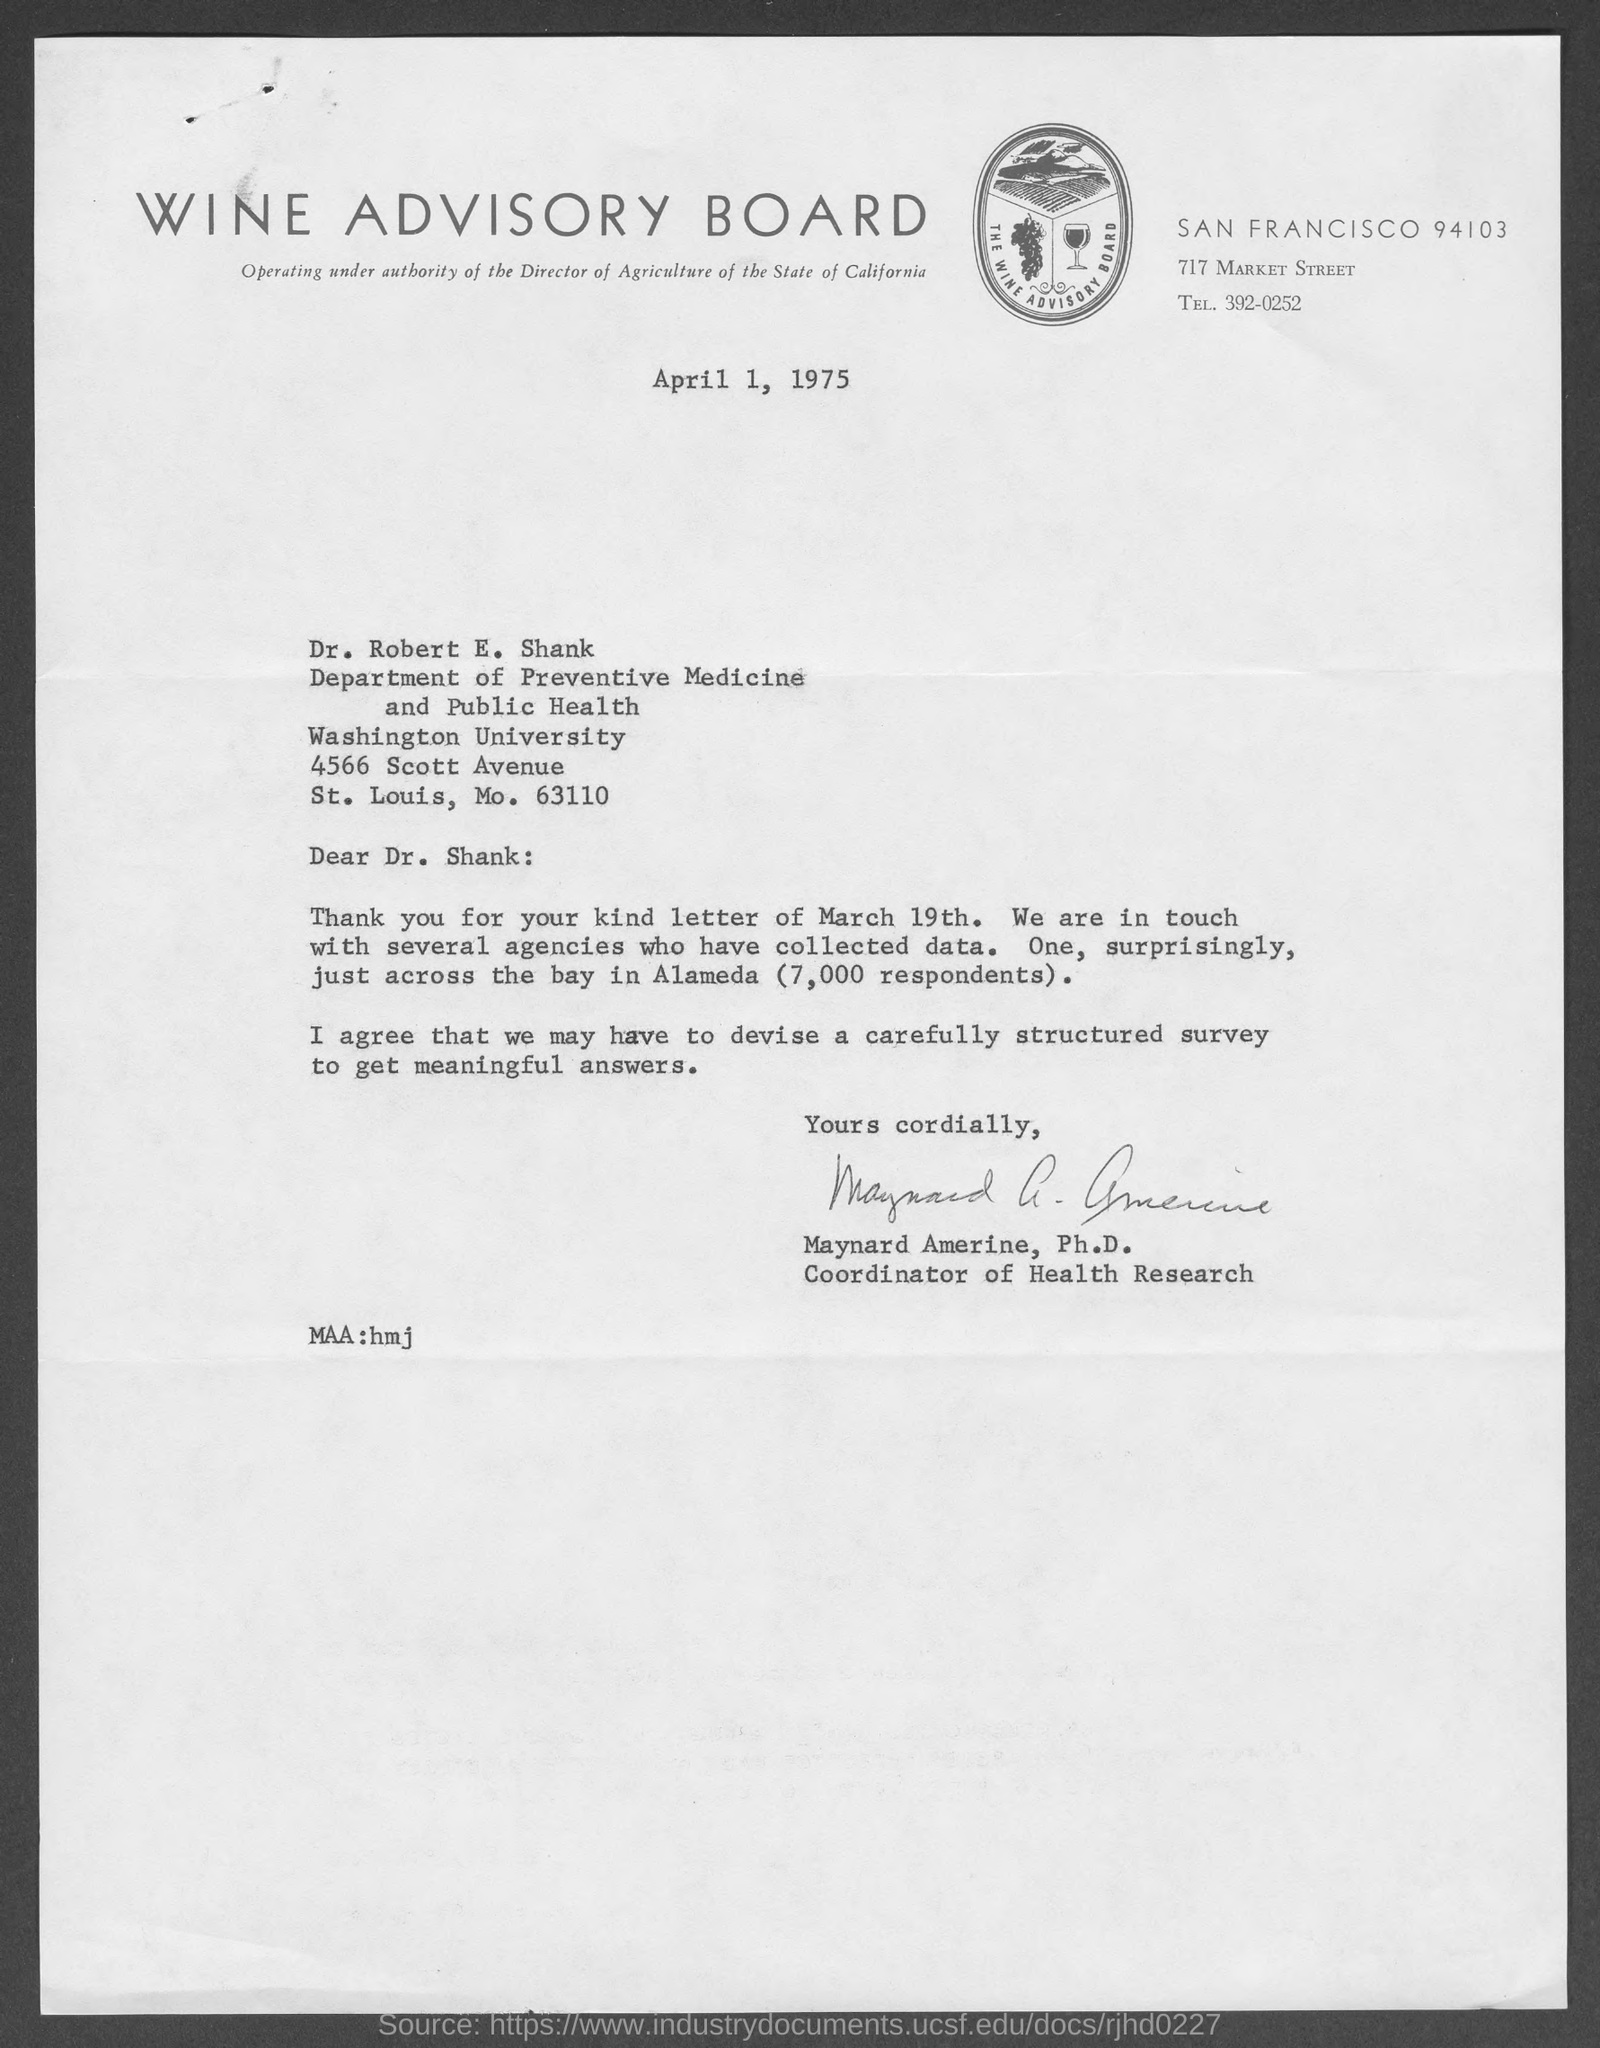Draw attention to some important aspects in this diagram. Maynard Amerine, Ph.D., is the coordinator of health research. The letter is from Maynard Amerine, Ph.D. 